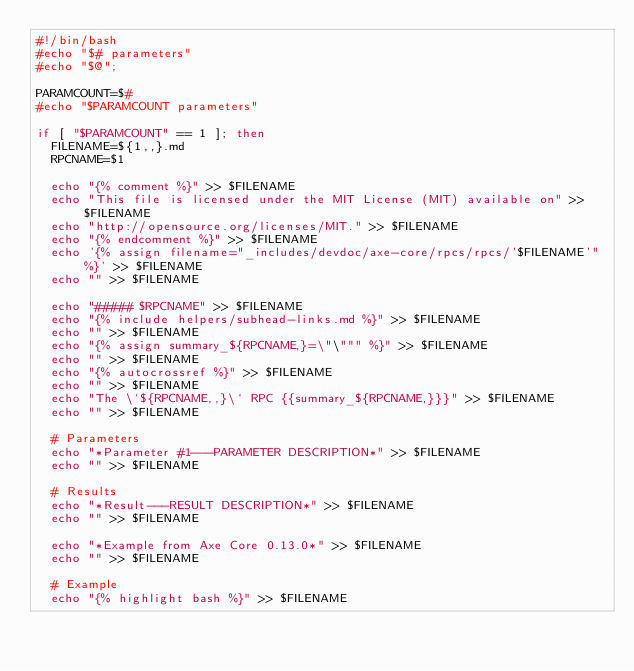<code> <loc_0><loc_0><loc_500><loc_500><_Bash_>#!/bin/bash
#echo "$# parameters"
#echo "$@";

PARAMCOUNT=$#
#echo "$PARAMCOUNT parameters"

if [ "$PARAMCOUNT" == 1 ]; then
	FILENAME=${1,,}.md
	RPCNAME=$1

	echo "{% comment %}" >> $FILENAME
	echo "This file is licensed under the MIT License (MIT) available on" >> $FILENAME
	echo "http://opensource.org/licenses/MIT." >> $FILENAME
	echo "{% endcomment %}" >> $FILENAME
	echo '{% assign filename="_includes/devdoc/axe-core/rpcs/rpcs/'$FILENAME'" %}' >> $FILENAME
	echo "" >> $FILENAME

	echo "##### $RPCNAME" >> $FILENAME
	echo "{% include helpers/subhead-links.md %}" >> $FILENAME
	echo "" >> $FILENAME
	echo "{% assign summary_${RPCNAME,}=\"\""" %}" >> $FILENAME
	echo "" >> $FILENAME
	echo "{% autocrossref %}" >> $FILENAME
	echo "" >> $FILENAME
	echo "The \`${RPCNAME,,}\` RPC {{summary_${RPCNAME,}}}" >> $FILENAME
	echo "" >> $FILENAME

	# Parameters
	echo "*Parameter #1---PARAMETER DESCRIPTION*" >> $FILENAME
	echo "" >> $FILENAME

	# Results
	echo "*Result---RESULT DESCRIPTION*" >> $FILENAME
	echo "" >> $FILENAME

	echo "*Example from Axe Core 0.13.0*" >> $FILENAME
	echo "" >> $FILENAME

	# Example
	echo "{% highlight bash %}" >> $FILENAME</code> 